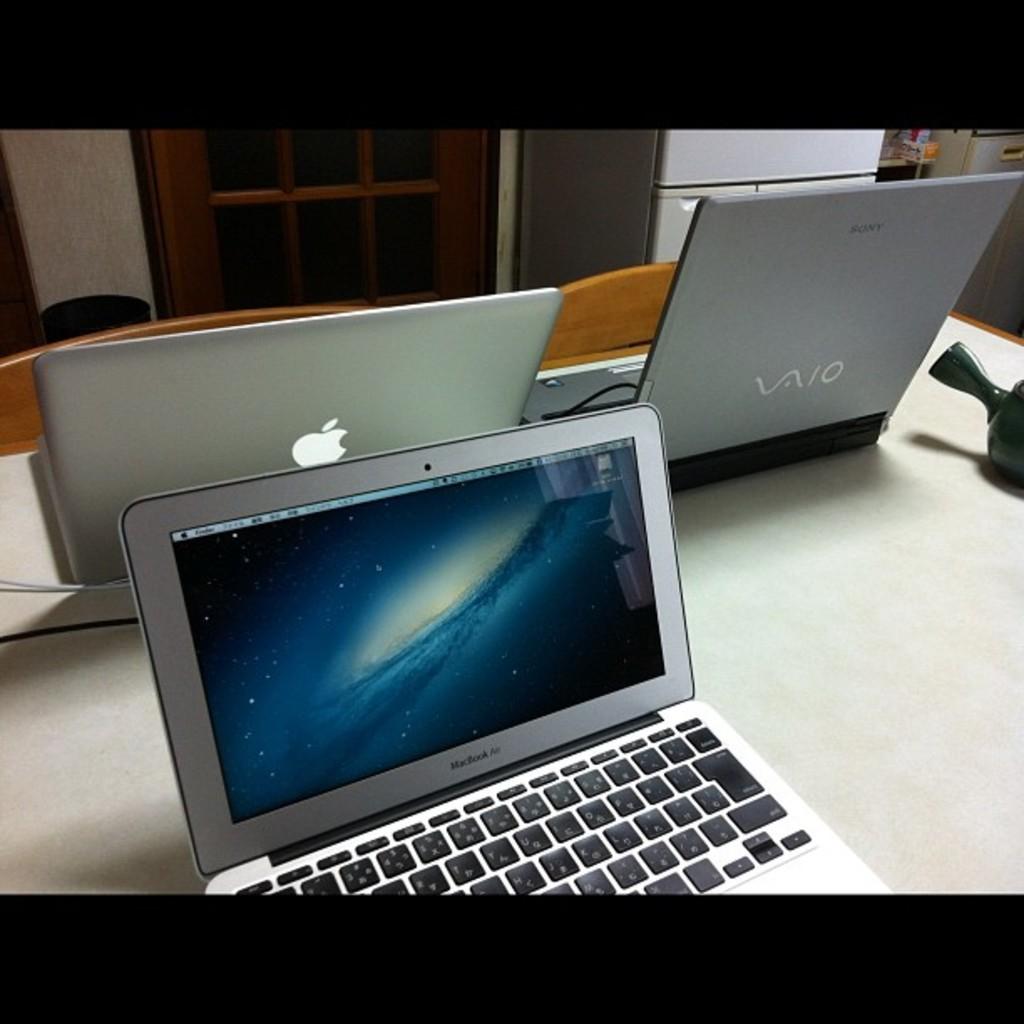What is the brand of laptop on top right?
Make the answer very short. Vaio. What is the model of the laoptop on the rigt?
Your answer should be compact. Vaio. 